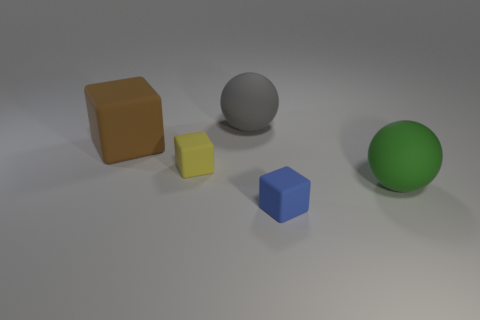Subtract all brown rubber blocks. How many blocks are left? 2 Add 2 matte balls. How many objects exist? 7 Subtract all yellow cubes. How many cubes are left? 2 Add 2 large matte balls. How many large matte balls are left? 4 Add 1 brown rubber spheres. How many brown rubber spheres exist? 1 Subtract 1 green balls. How many objects are left? 4 Subtract all blocks. How many objects are left? 2 Subtract 3 blocks. How many blocks are left? 0 Subtract all cyan spheres. Subtract all gray cubes. How many spheres are left? 2 Subtract all yellow objects. Subtract all small purple cylinders. How many objects are left? 4 